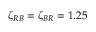<formula> <loc_0><loc_0><loc_500><loc_500>\zeta _ { R B } = \zeta _ { B R } = 1 . 2 5</formula> 